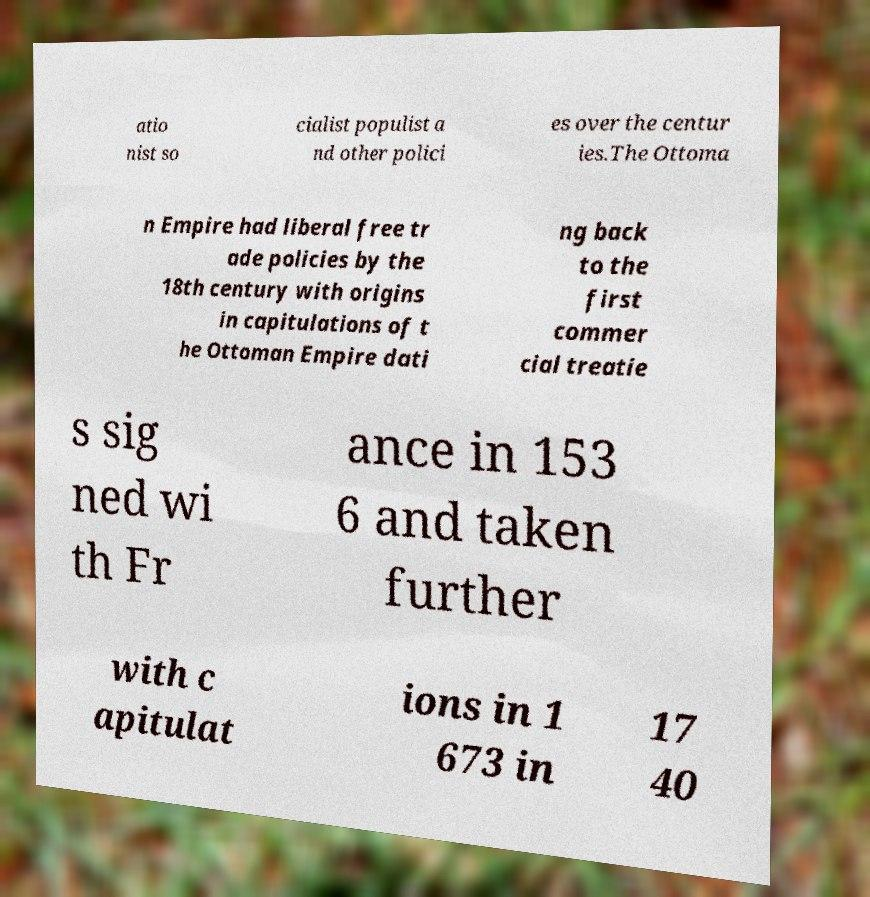I need the written content from this picture converted into text. Can you do that? atio nist so cialist populist a nd other polici es over the centur ies.The Ottoma n Empire had liberal free tr ade policies by the 18th century with origins in capitulations of t he Ottoman Empire dati ng back to the first commer cial treatie s sig ned wi th Fr ance in 153 6 and taken further with c apitulat ions in 1 673 in 17 40 